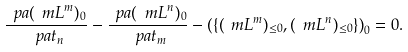<formula> <loc_0><loc_0><loc_500><loc_500>\frac { \ p a ( \ m L ^ { m } ) _ { 0 } } { \ p a t _ { n } } - \frac { \ p a ( \ m L ^ { n } ) _ { 0 } } { \ p a t _ { m } } - \left ( \{ ( \ m L ^ { m } ) _ { \leq 0 } , ( \ m L ^ { n } ) _ { \leq 0 } \} \right ) _ { 0 } = 0 .</formula> 